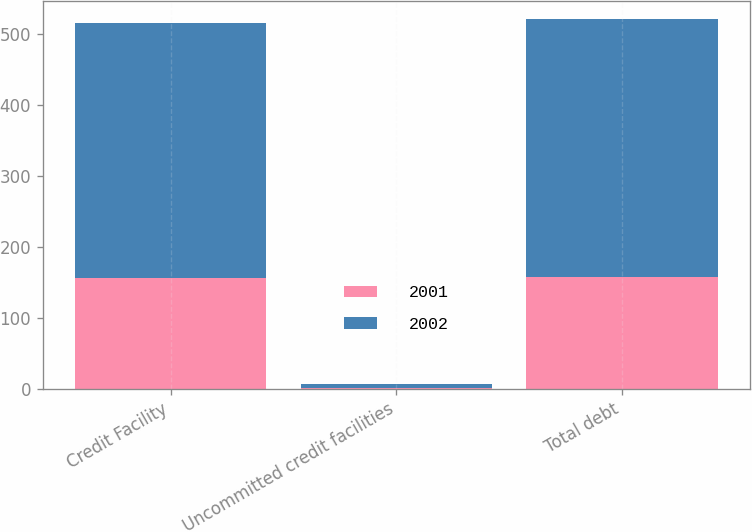Convert chart. <chart><loc_0><loc_0><loc_500><loc_500><stacked_bar_chart><ecel><fcel>Credit Facility<fcel>Uncommitted credit facilities<fcel>Total debt<nl><fcel>2001<fcel>156.2<fcel>0.5<fcel>156.7<nl><fcel>2002<fcel>358.2<fcel>5.7<fcel>363.9<nl></chart> 